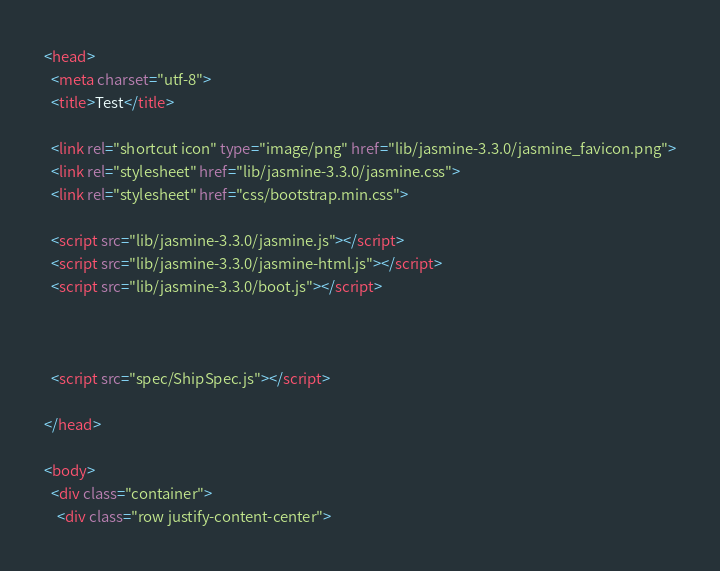<code> <loc_0><loc_0><loc_500><loc_500><_HTML_><head>
  <meta charset="utf-8">
  <title>Test</title>

  <link rel="shortcut icon" type="image/png" href="lib/jasmine-3.3.0/jasmine_favicon.png">
  <link rel="stylesheet" href="lib/jasmine-3.3.0/jasmine.css">
  <link rel="stylesheet" href="css/bootstrap.min.css">

  <script src="lib/jasmine-3.3.0/jasmine.js"></script>
  <script src="lib/jasmine-3.3.0/jasmine-html.js"></script>
  <script src="lib/jasmine-3.3.0/boot.js"></script>



  <script src="spec/ShipSpec.js"></script>

</head>

<body>
  <div class="container">
    <div class="row justify-content-center"></code> 